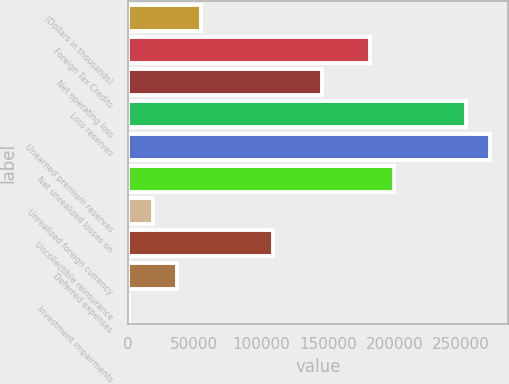Convert chart. <chart><loc_0><loc_0><loc_500><loc_500><bar_chart><fcel>(Dollars in thousands)<fcel>Foreign Tax Credits<fcel>Net operating loss<fcel>Loss reserves<fcel>Unearned premium reserves<fcel>Net unrealized losses on<fcel>Unrealized foreign currency<fcel>Uncollectible reinsurance<fcel>Deferred expenses<fcel>Investment impairments<nl><fcel>55223.5<fcel>181409<fcel>145356<fcel>253515<fcel>271542<fcel>199436<fcel>19170.5<fcel>109303<fcel>37197<fcel>1144<nl></chart> 